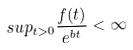Convert formula to latex. <formula><loc_0><loc_0><loc_500><loc_500>s u p _ { t > 0 } \frac { f ( t ) } { e ^ { b t } } < \infty</formula> 